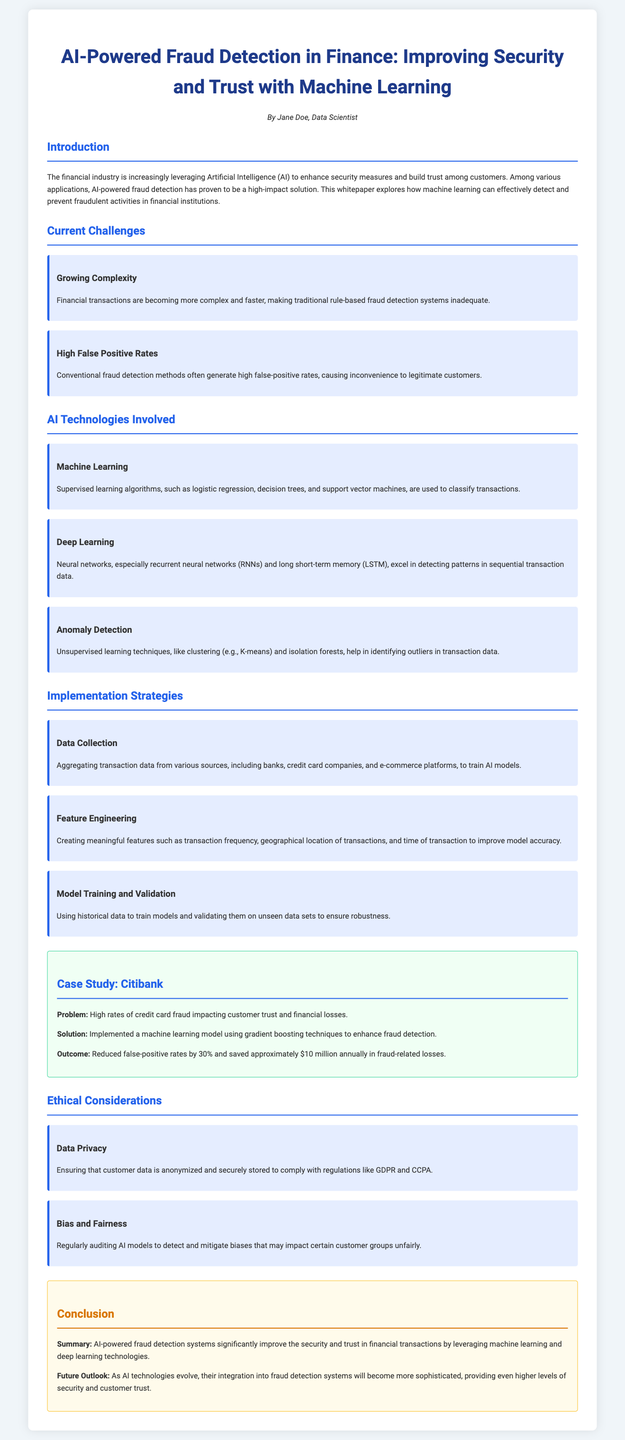what is the title of the whitepaper? The title is prominently displayed at the top of the document.
Answer: AI-Powered Fraud Detection in Finance: Improving Security and Trust with Machine Learning who is the author of the document? The author's name is listed under the title.
Answer: Jane Doe which machine learning algorithm is mentioned for classification? The algorithms are listed in the section about AI technologies involved.
Answer: Logistic regression, decision trees, and support vector machines what was the outcome of the Citibank case study? The results of the case study are detailed in its conclusion.
Answer: Reduced false-positive rates by 30% and saved approximately $10 million annually in fraud-related losses what ethical consideration is related to customer data? The specific ethical issues are addressed in the relevant section.
Answer: Data Privacy what future outlook is mentioned for AI in fraud detection? The future outlook is discussed in the conclusion section.
Answer: More sophisticated integration how does traditional fraud detection impact legitimate customers? The challenges are outlined in the section on current challenges.
Answer: High false positive rates what technology is specifically highlighted for detecting patterns in sequential data? This technology is emphasized in the AI technologies section.
Answer: Neural networks, especially recurrent neural networks (RNNs) and long short-term memory (LSTM) 